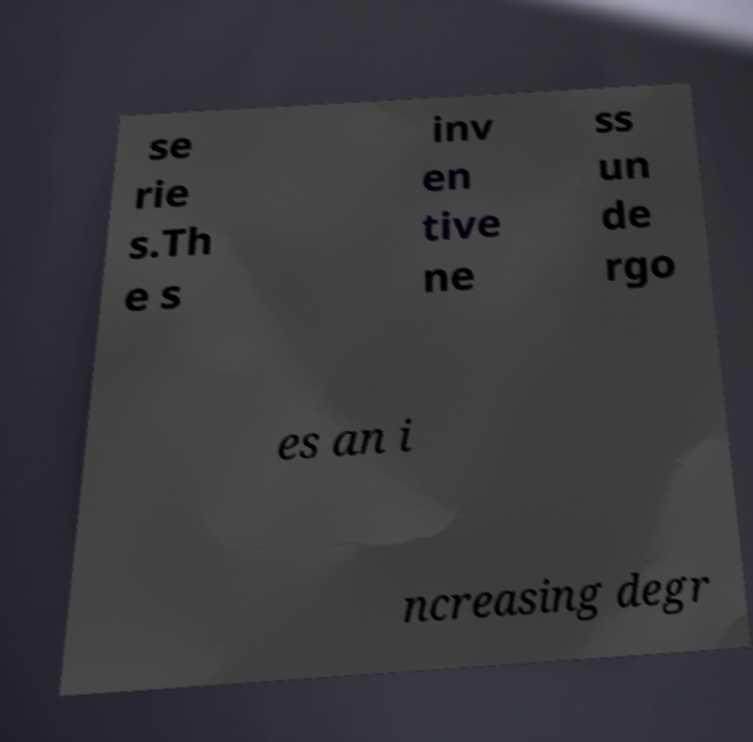What messages or text are displayed in this image? I need them in a readable, typed format. se rie s.Th e s inv en tive ne ss un de rgo es an i ncreasing degr 